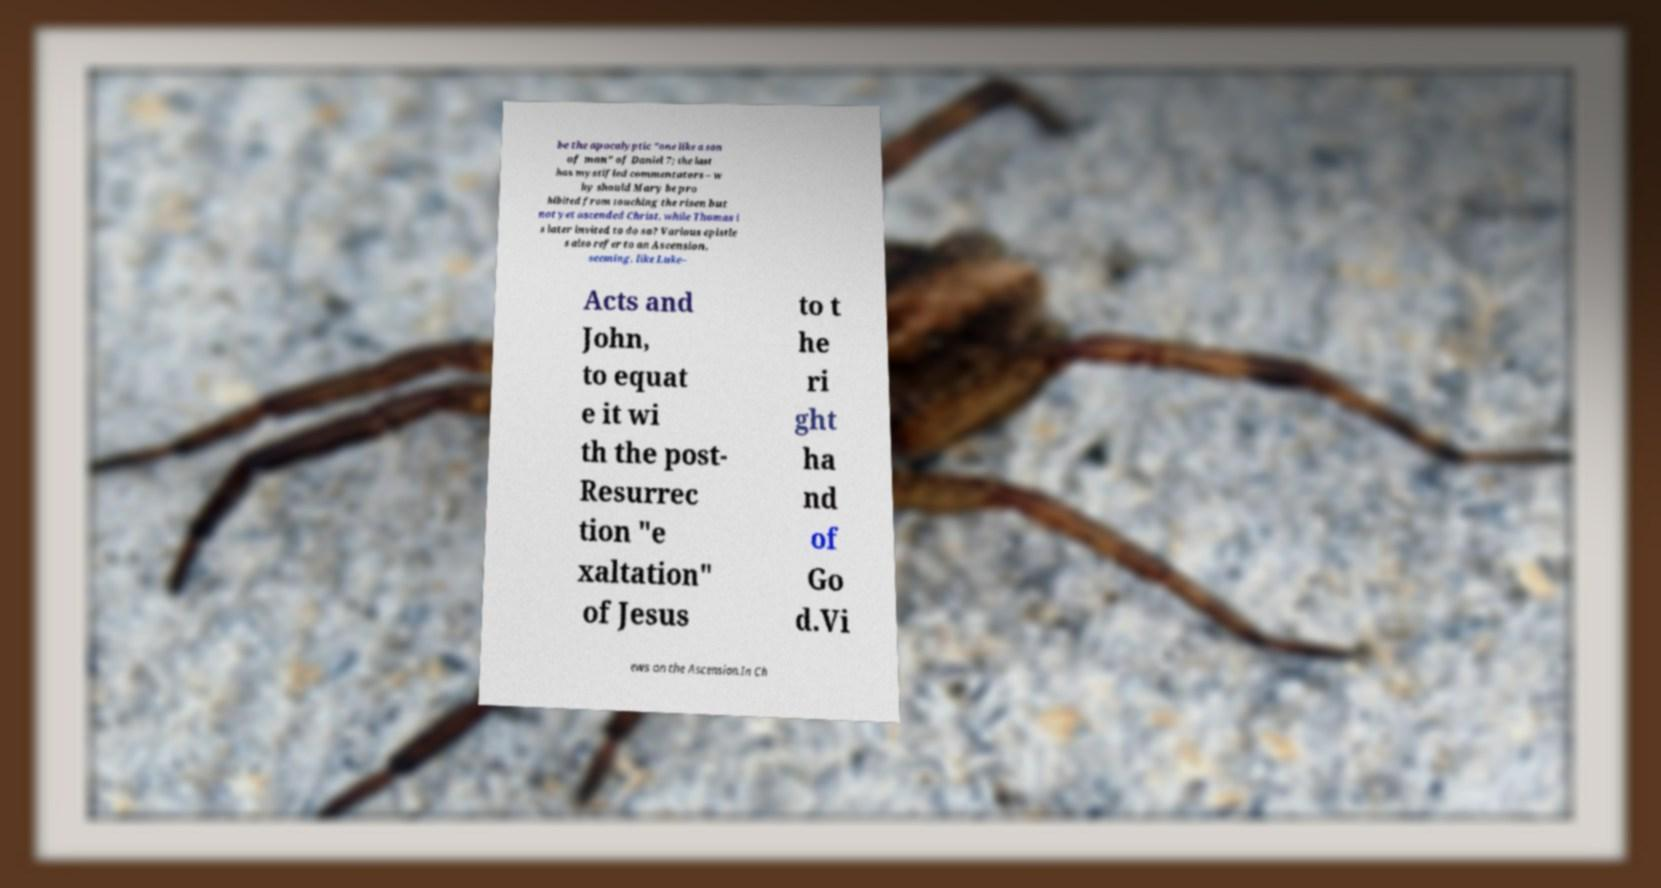For documentation purposes, I need the text within this image transcribed. Could you provide that? be the apocalyptic "one like a son of man" of Daniel 7; the last has mystified commentators – w hy should Mary be pro hibited from touching the risen but not yet ascended Christ, while Thomas i s later invited to do so? Various epistle s also refer to an Ascension, seeming, like Luke– Acts and John, to equat e it wi th the post- Resurrec tion "e xaltation" of Jesus to t he ri ght ha nd of Go d.Vi ews on the Ascension.In Ch 